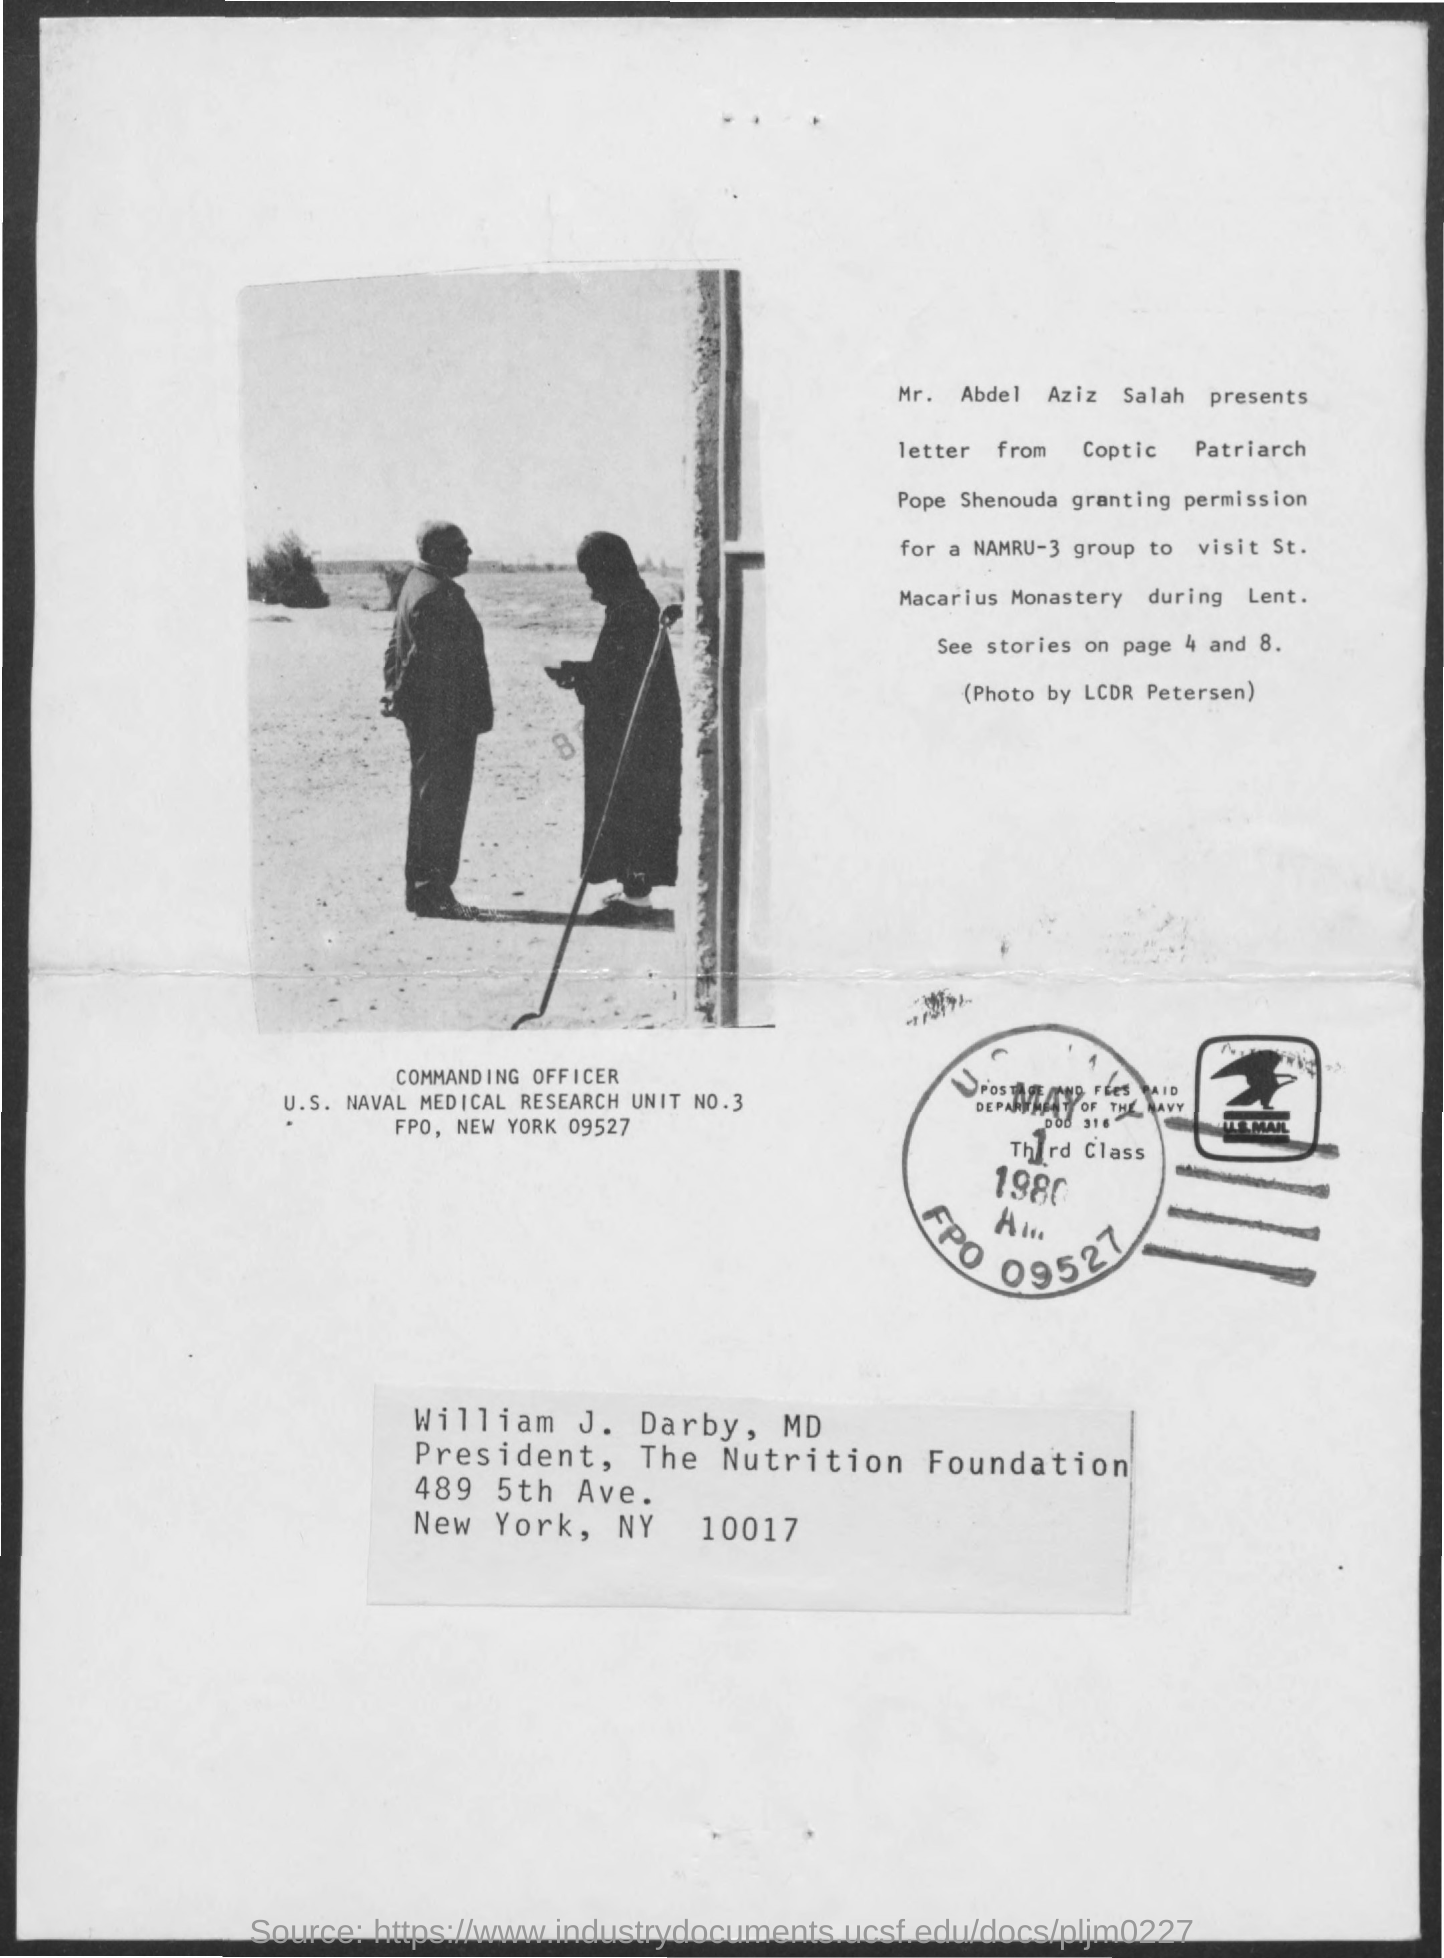Who presents the letter?
Offer a terse response. Mr. Abdel Aziz Salah. Mr. Abdel Aziz Salah present letter from whom?
Give a very brief answer. Coptic Patriarch Pope Shenouda. Granting permission to whom?
Provide a short and direct response. NAMRU-3 group. The permission was granted to visit which monastery?
Offer a very short reply. St. Macarius Monastery. 